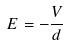Convert formula to latex. <formula><loc_0><loc_0><loc_500><loc_500>E = - \frac { V } { d }</formula> 